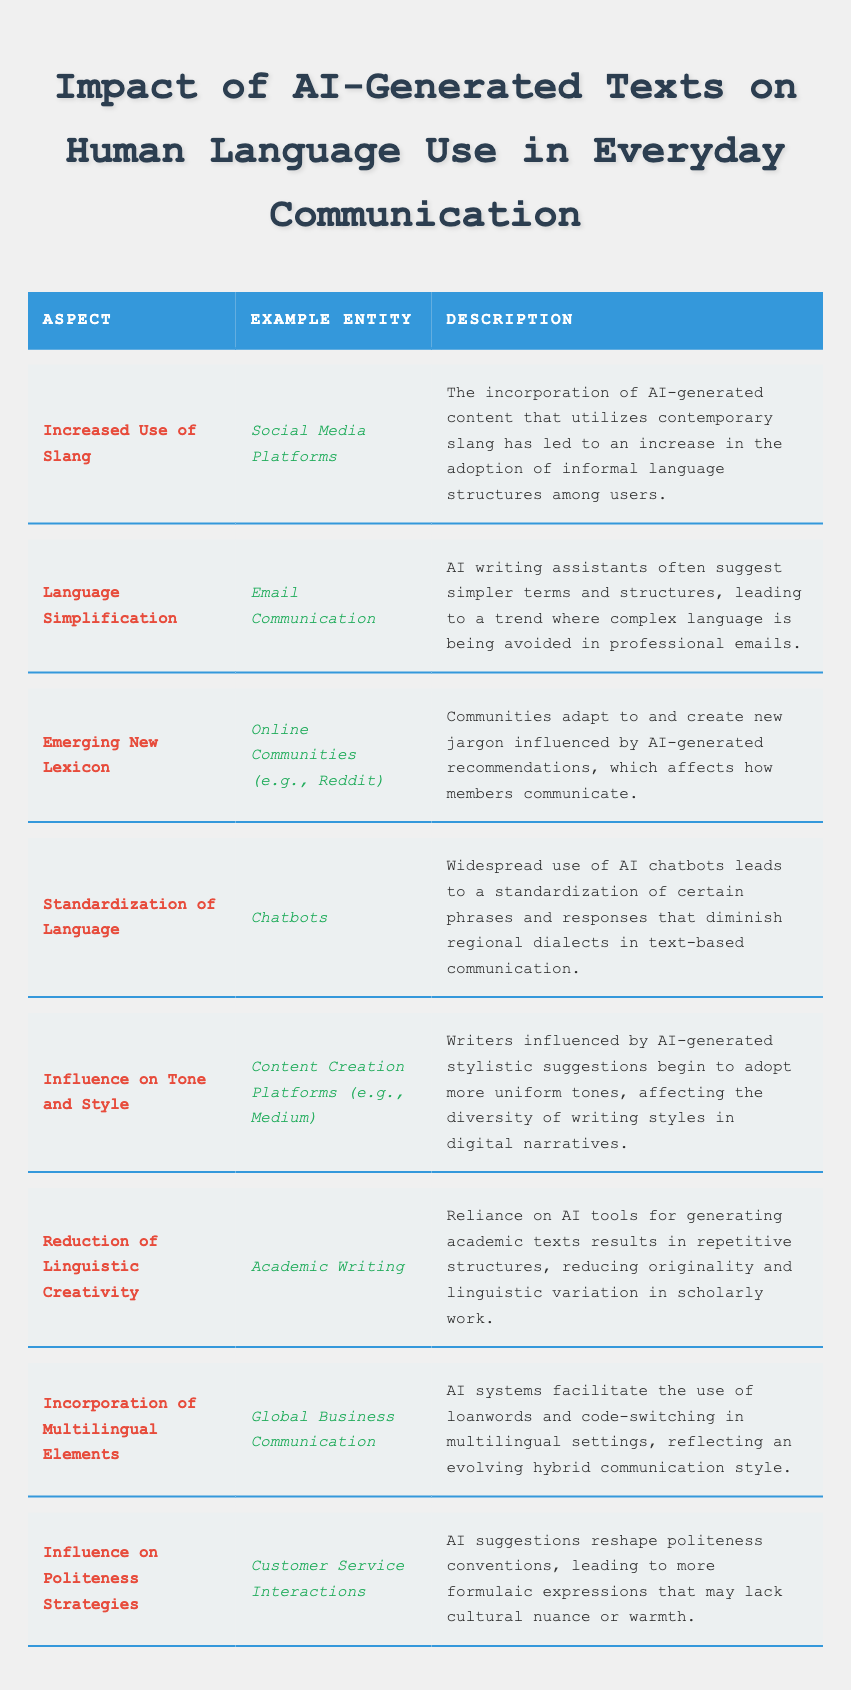What aspect is related to "Social Media Platforms"? The table lists "Increased Use of Slang" under the "Example Entity" of "Social Media Platforms."
Answer: Increased Use of Slang What does the "Reduction of Linguistic Creativity" refer to? It refers to the reliance on AI tools in academic writing, which leads to repetitive structures and less originality.
Answer: Reliance on AI tools in academic writing How many aspects are mentioned in the table? The table lists eight different aspects related to the impact of AI-generated texts on language use.
Answer: Eight Which aspect is associated with "Chatbots"? The aspect associated with "Chatbots" is "Standardization of Language," reflecting the impact of AI on reducing dialectal variations.
Answer: Standardization of Language Is "Emerging New Lexicon" linked to "Reddit"? Yes, the aspect "Emerging New Lexicon" is specifically linked to online communities, including Reddit.
Answer: Yes What do "Content Creation Platforms" influence according to the table? "Content Creation Platforms" influence the "Tone and Style" of writing, leading to a more uniform tone among writers.
Answer: Tone and Style Which aspect involves the use of loanwords in communication? The aspect that involves the use of loanwords is "Incorporation of Multilingual Elements" in global business communication.
Answer: Incorporation of Multilingual Elements What is the relationship between "Customer Service Interactions" and politeness strategies? The table indicates that AI suggestions in "Customer Service Interactions" reshape politeness strategies, making them more formulaic.
Answer: They become more formulaic Which example entity shows an increase in informal language structures? "Social Media Platforms" show an increase in informal language structures due to the use of AI-generated content with slang.
Answer: Social Media Platforms If we consider the aspects related to text simplification, what is emphasized? The table emphasizes that language simplification is particularly relevant to email communication and the avoidance of complex language.
Answer: Email Communication 